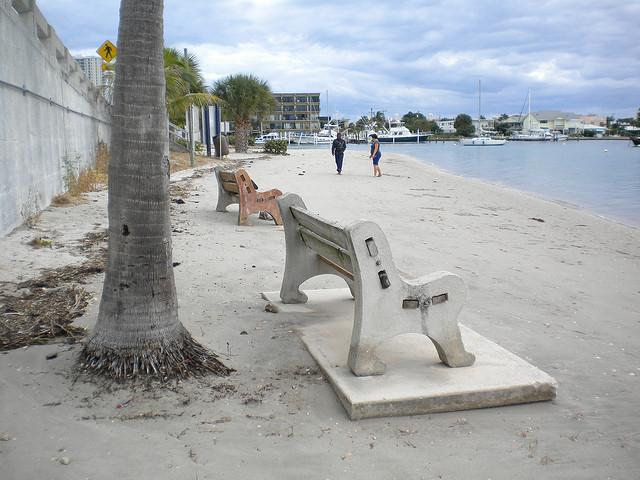What are the benches for? sitting 